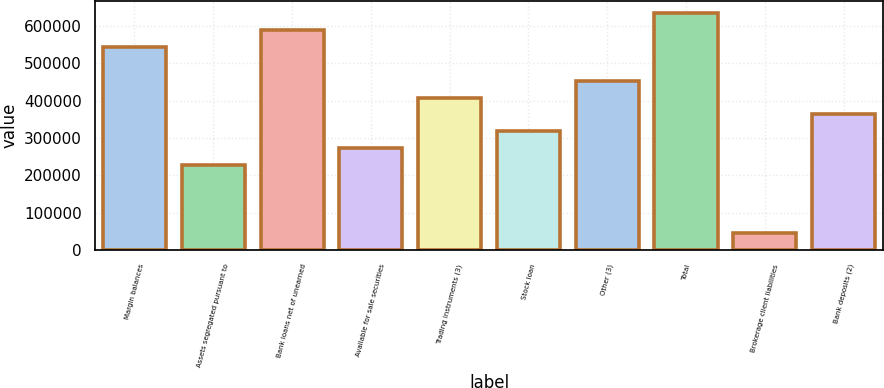<chart> <loc_0><loc_0><loc_500><loc_500><bar_chart><fcel>Margin balances<fcel>Assets segregated pursuant to<fcel>Bank loans net of unearned<fcel>Available for sale securities<fcel>Trading instruments (3)<fcel>Stock loan<fcel>Other (3)<fcel>Total<fcel>Brokerage client liabilities<fcel>Bank deposits (2)<nl><fcel>543514<fcel>227617<fcel>588643<fcel>272745<fcel>408130<fcel>317873<fcel>453258<fcel>633771<fcel>47104.2<fcel>363002<nl></chart> 